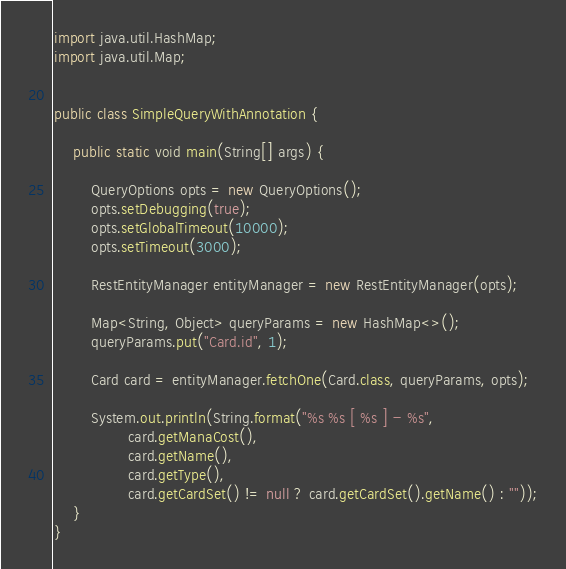Convert code to text. <code><loc_0><loc_0><loc_500><loc_500><_Java_>import java.util.HashMap;
import java.util.Map;


public class SimpleQueryWithAnnotation {

    public static void main(String[] args) {

        QueryOptions opts = new QueryOptions();
        opts.setDebugging(true);
        opts.setGlobalTimeout(10000);
        opts.setTimeout(3000);

        RestEntityManager entityManager = new RestEntityManager(opts);

        Map<String, Object> queryParams = new HashMap<>();
        queryParams.put("Card.id", 1);

        Card card = entityManager.fetchOne(Card.class, queryParams, opts);

        System.out.println(String.format("%s %s [ %s ] - %s",
                card.getManaCost(),
                card.getName(),
                card.getType(),
                card.getCardSet() != null ? card.getCardSet().getName() : ""));
    }
}
</code> 